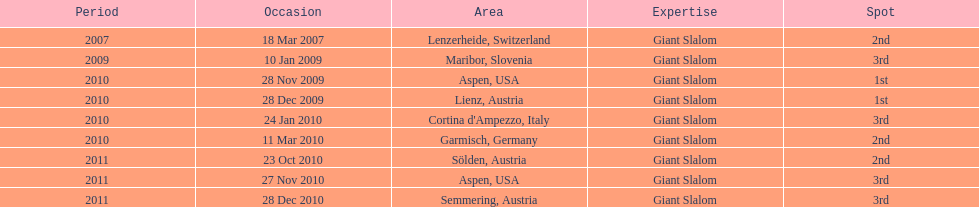Where was her first win? Aspen, USA. 